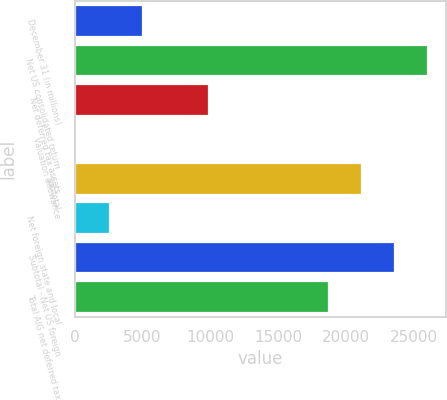Convert chart. <chart><loc_0><loc_0><loc_500><loc_500><bar_chart><fcel>December 31 (in millions)<fcel>Net US consolidated return<fcel>Net deferred tax assets<fcel>Valuation allowance<fcel>Subtotal<fcel>Net foreign state and local<fcel>Subtotal - Net US foreign<fcel>Total AIG net deferred tax<nl><fcel>5011.8<fcel>26069.2<fcel>9894.6<fcel>129<fcel>21186.4<fcel>2570.4<fcel>23627.8<fcel>18745<nl></chart> 